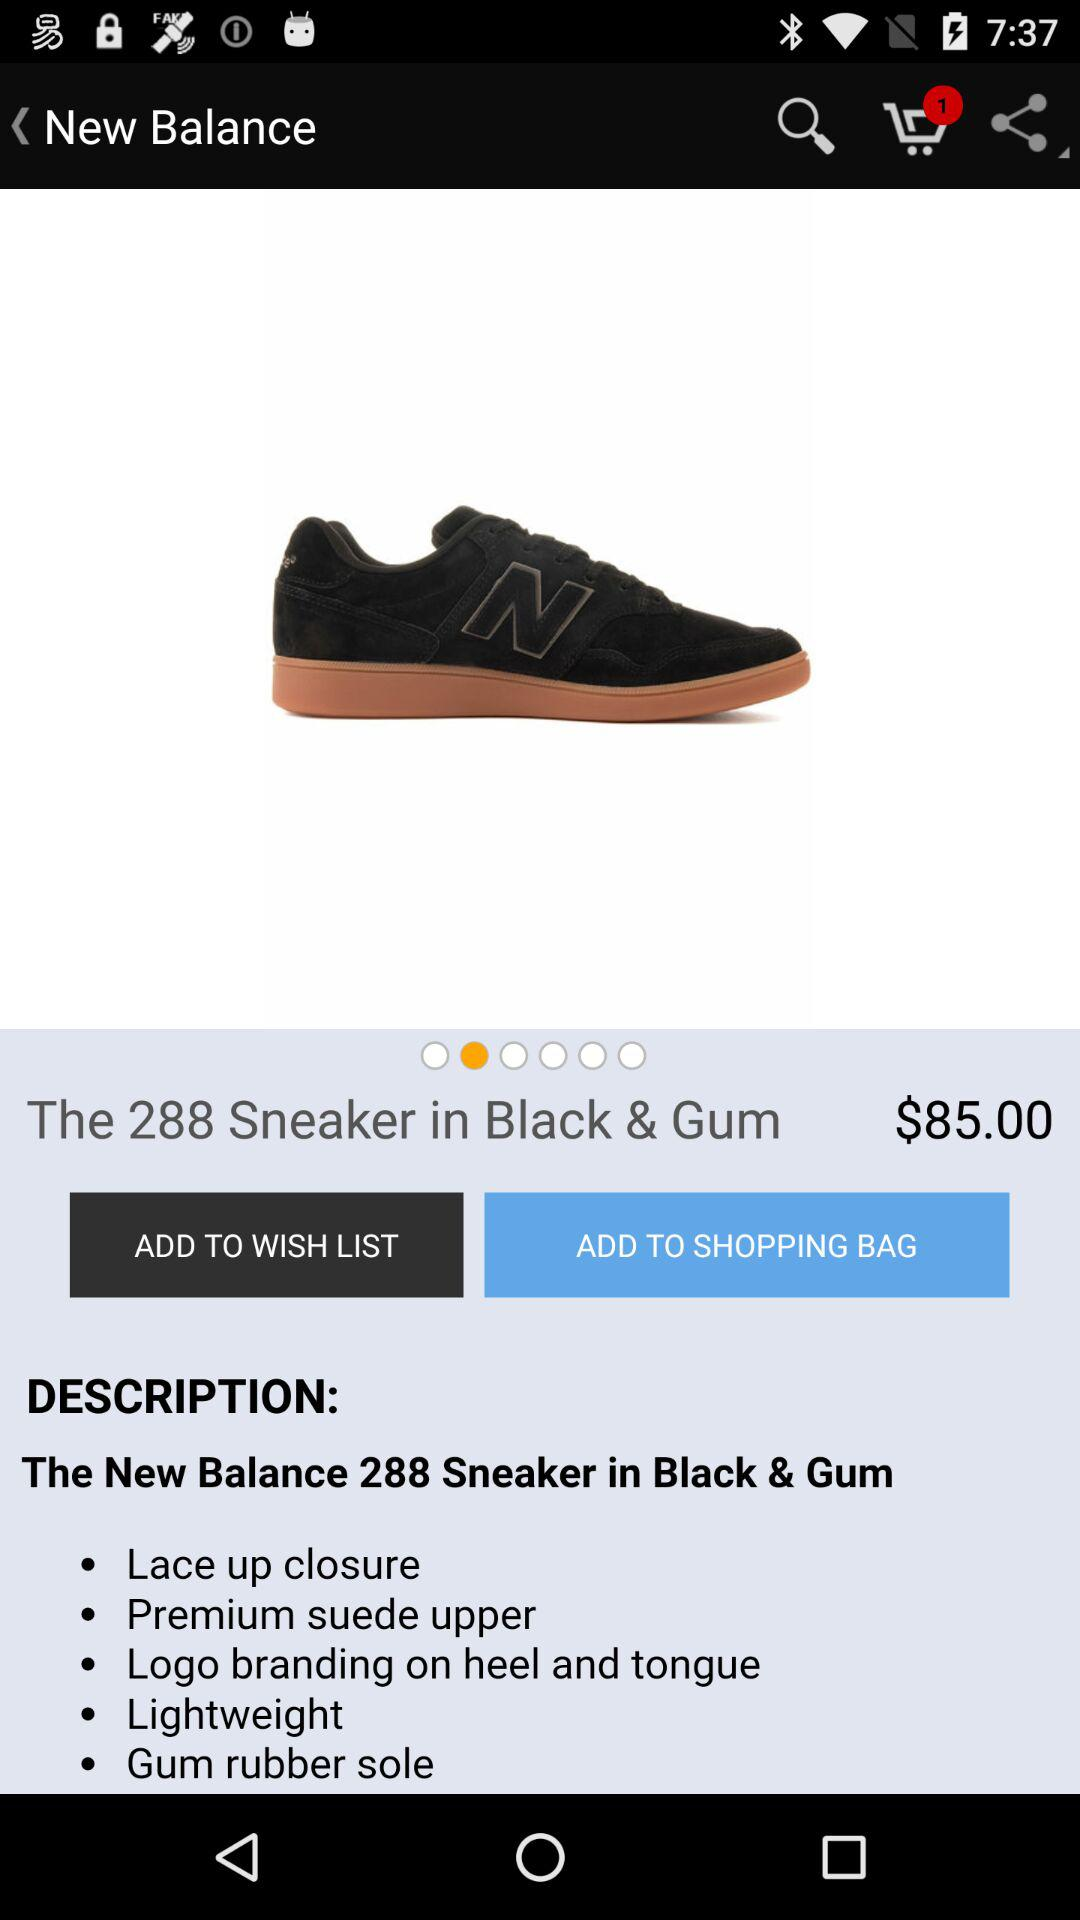What is the price of the product? The price of the product is $85.00. 